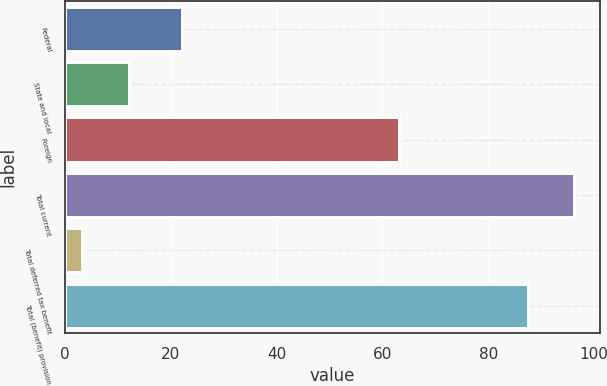<chart> <loc_0><loc_0><loc_500><loc_500><bar_chart><fcel>Federal<fcel>State and local<fcel>Foreign<fcel>Total current<fcel>Total deferred tax benefit<fcel>Total (benefit) provision<nl><fcel>22.1<fcel>12.05<fcel>63.1<fcel>96.25<fcel>3.3<fcel>87.5<nl></chart> 